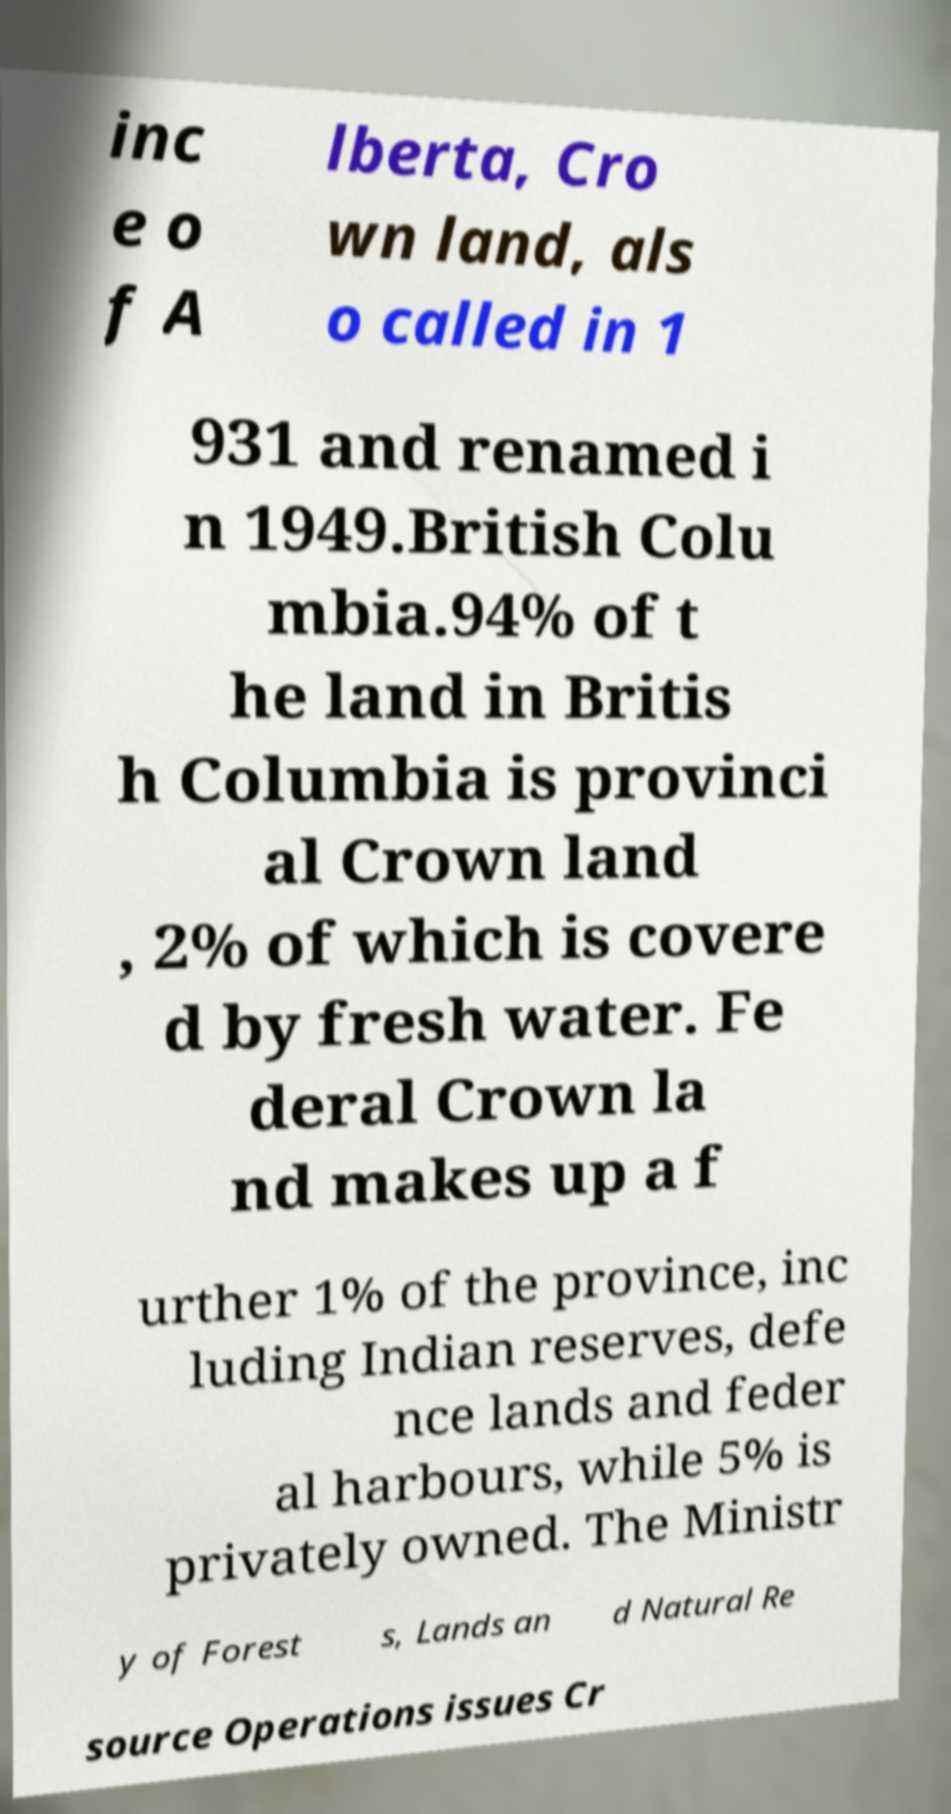Please read and relay the text visible in this image. What does it say? inc e o f A lberta, Cro wn land, als o called in 1 931 and renamed i n 1949.British Colu mbia.94% of t he land in Britis h Columbia is provinci al Crown land , 2% of which is covere d by fresh water. Fe deral Crown la nd makes up a f urther 1% of the province, inc luding Indian reserves, defe nce lands and feder al harbours, while 5% is privately owned. The Ministr y of Forest s, Lands an d Natural Re source Operations issues Cr 